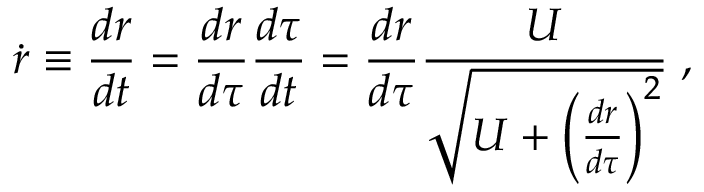Convert formula to latex. <formula><loc_0><loc_0><loc_500><loc_500>\dot { r } \equiv \frac { d r } { d t } = { \frac { d r } { d \tau } } { \frac { d \tau } { d t } } = { \frac { d r } { d \tau } } { \frac { U } { \sqrt { U + \left ( { \frac { d r } { d \tau } } \right ) ^ { 2 } } } } \, ,</formula> 